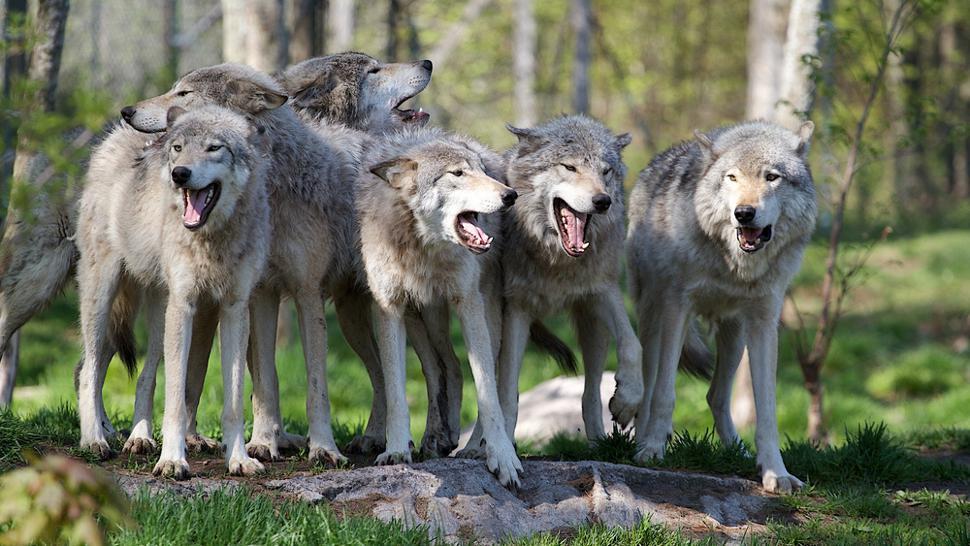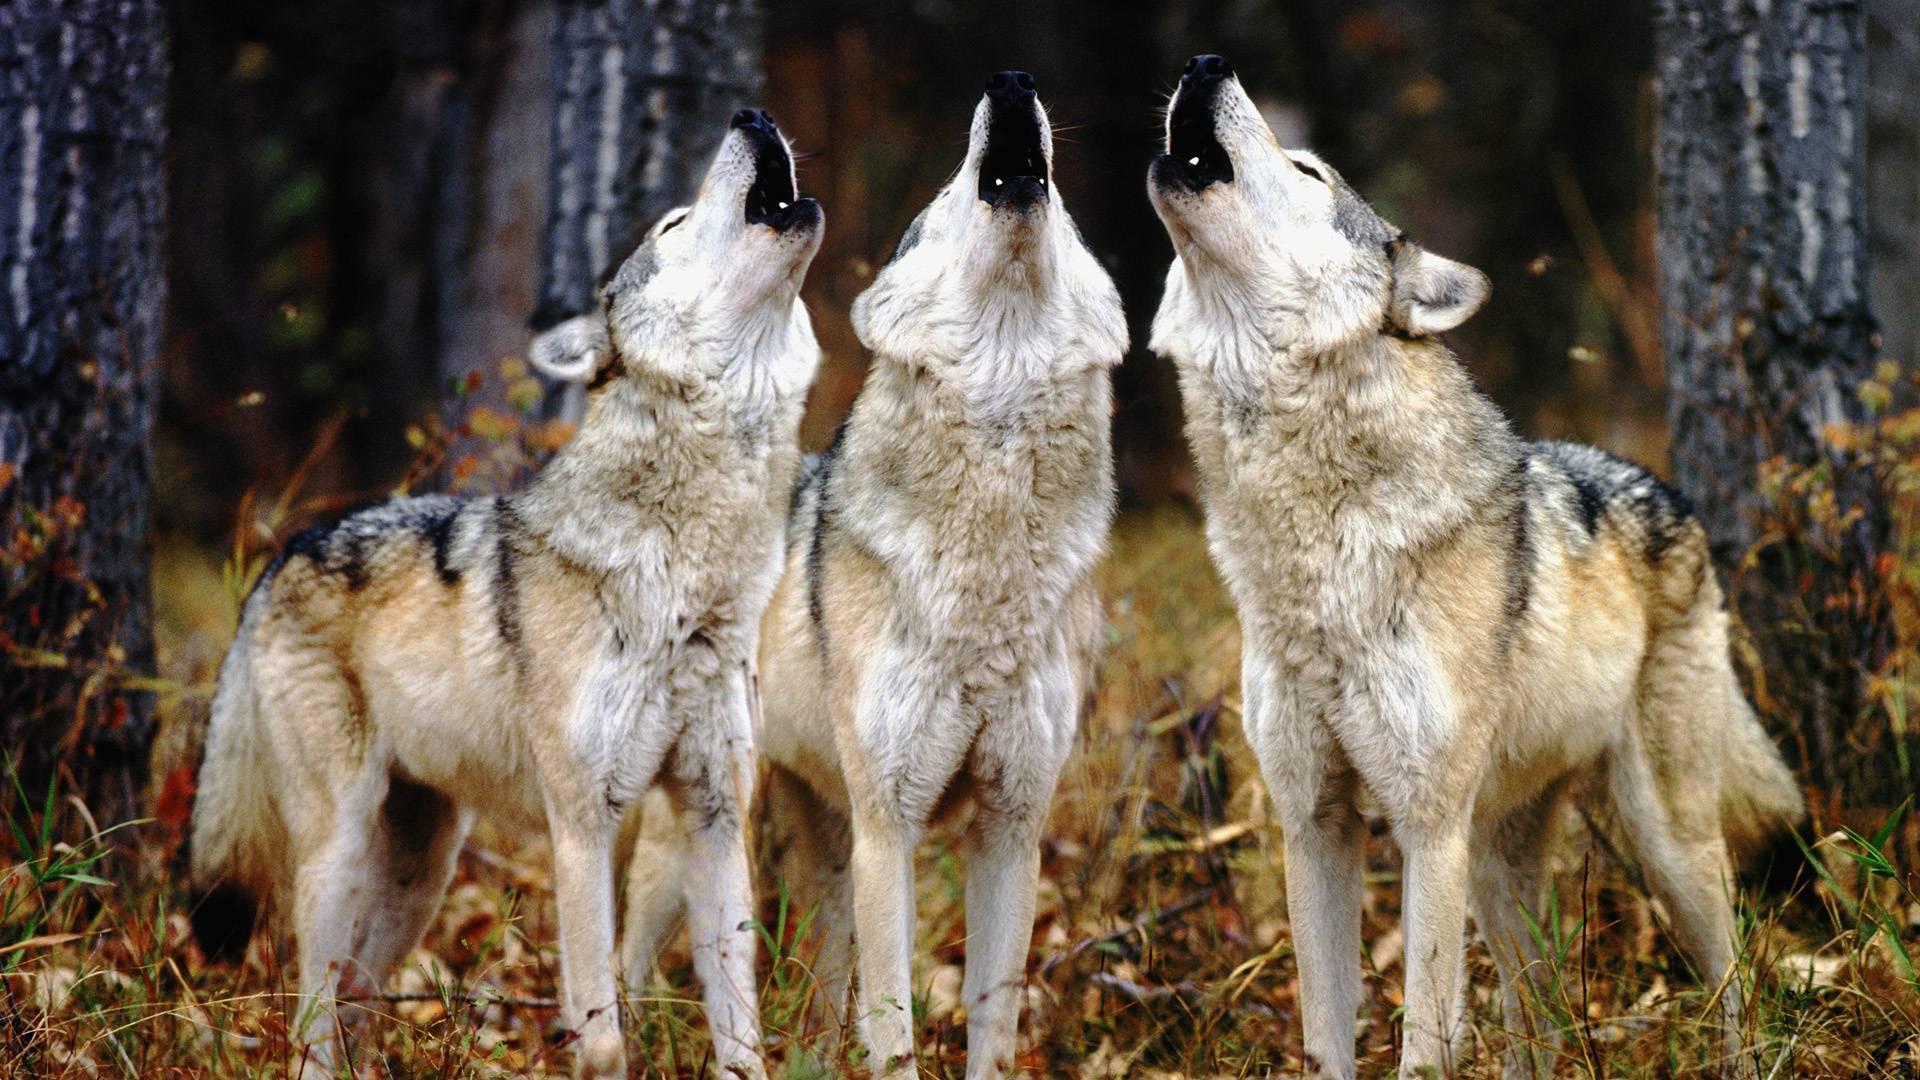The first image is the image on the left, the second image is the image on the right. Evaluate the accuracy of this statement regarding the images: "There are only two wolves.". Is it true? Answer yes or no. No. The first image is the image on the left, the second image is the image on the right. Evaluate the accuracy of this statement regarding the images: "One image contains exactly three wolves posed in a row with their bodies angled forward.". Is it true? Answer yes or no. Yes. 